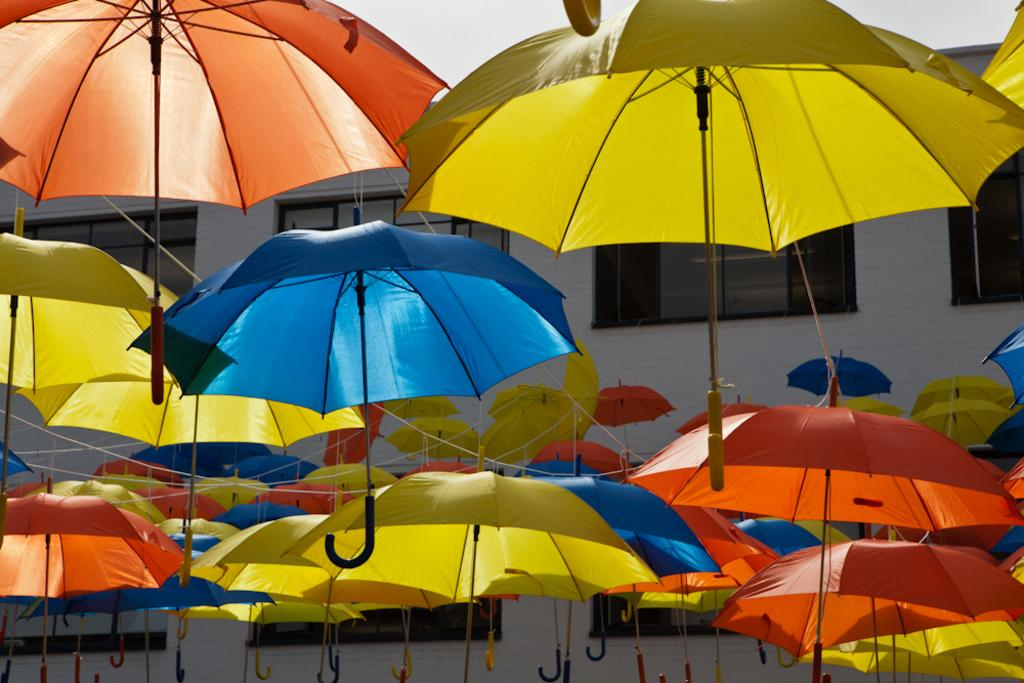What objects can be seen in the image? There are umbrellas in the image. What colors are the umbrellas? The umbrellas have colors: yellow, red, and blue. How are the umbrellas secured? The umbrellas are tied with strings. Where are the umbrellas located in relation to the building? The umbrellas are near a building. What is the color of the building? The building is white in color. What feature does the building have? The building has windows. What type of group can be seen making noise near the building in the image? There is no group or noise present in the image; it only features umbrellas and a building. What kind of ray is emitting from the umbrellas in the image? There is no ray emitting from the umbrellas in the image. 